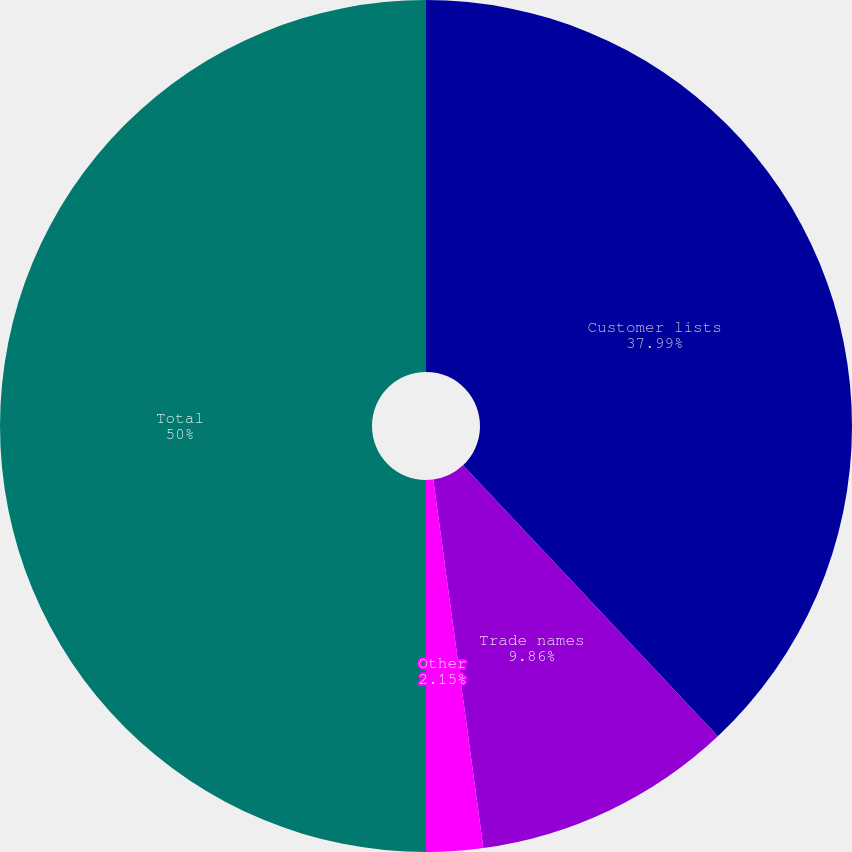<chart> <loc_0><loc_0><loc_500><loc_500><pie_chart><fcel>Customer lists<fcel>Trade names<fcel>Other<fcel>Total<nl><fcel>37.99%<fcel>9.86%<fcel>2.15%<fcel>50.0%<nl></chart> 